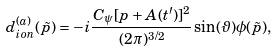Convert formula to latex. <formula><loc_0><loc_0><loc_500><loc_500>d _ { i o n } ^ { ( a ) } ( \tilde { p } ) = - i \frac { C _ { \psi } [ p + A ( t ^ { \prime } ) ] ^ { 2 } } { ( 2 \pi ) ^ { 3 / 2 } } \sin ( \vartheta ) \phi ( \tilde { p } ) ,</formula> 